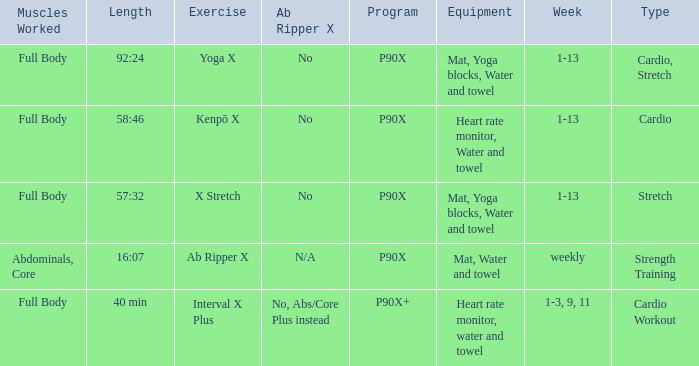How many types are cardio? 1.0. 